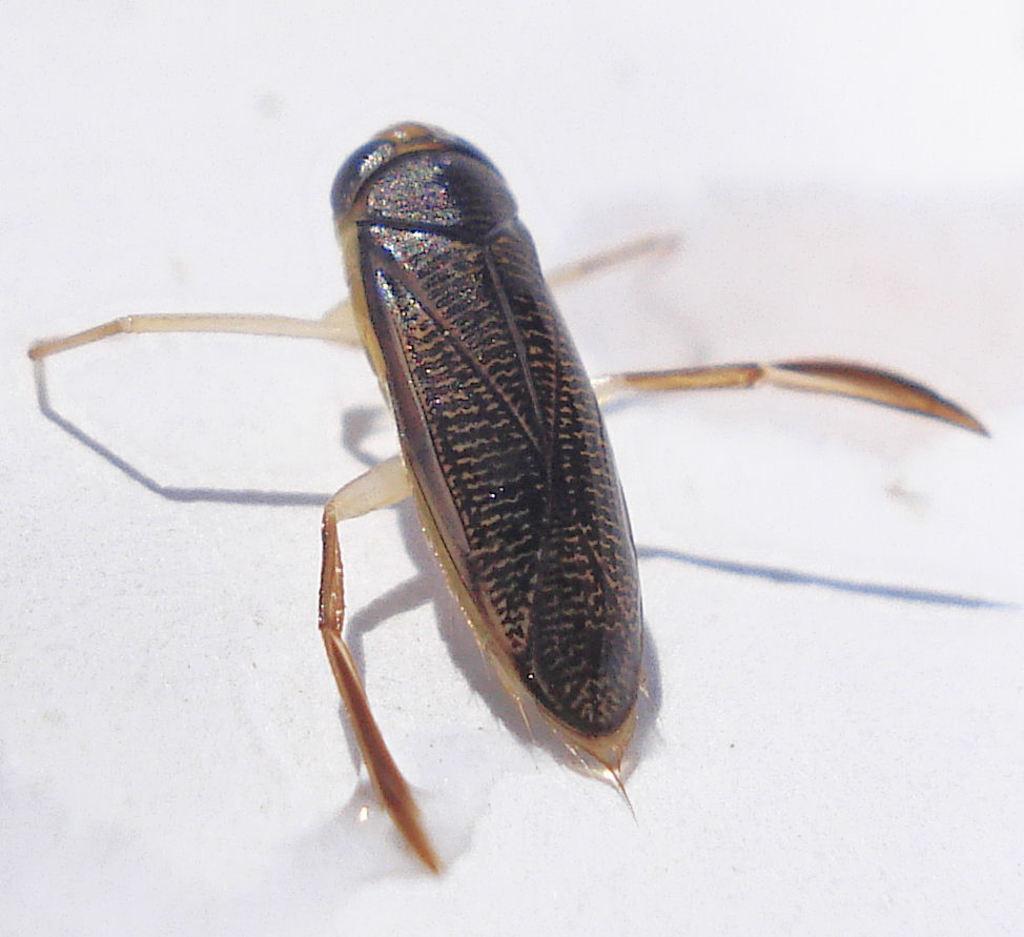How would you summarize this image in a sentence or two? In this image, I can see an insect with legs. The background looks white in color. 